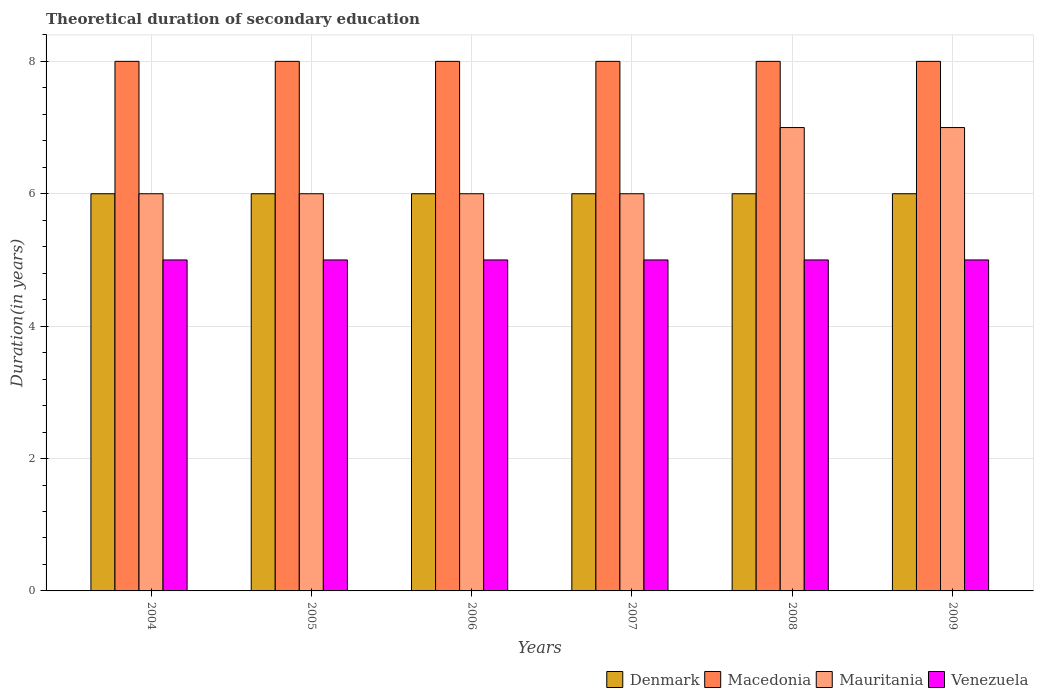How many different coloured bars are there?
Your answer should be very brief. 4. Are the number of bars per tick equal to the number of legend labels?
Offer a very short reply. Yes. Are the number of bars on each tick of the X-axis equal?
Give a very brief answer. Yes. How many bars are there on the 1st tick from the left?
Provide a succinct answer. 4. What is the label of the 4th group of bars from the left?
Your answer should be compact. 2007. In how many cases, is the number of bars for a given year not equal to the number of legend labels?
Your response must be concise. 0. What is the total theoretical duration of secondary education in Venezuela in 2004?
Provide a short and direct response. 5. Across all years, what is the maximum total theoretical duration of secondary education in Venezuela?
Your answer should be compact. 5. What is the total total theoretical duration of secondary education in Venezuela in the graph?
Ensure brevity in your answer.  30. What is the difference between the total theoretical duration of secondary education in Mauritania in 2006 and that in 2009?
Your response must be concise. -1. What is the difference between the total theoretical duration of secondary education in Denmark in 2005 and the total theoretical duration of secondary education in Mauritania in 2009?
Provide a short and direct response. -1. What is the average total theoretical duration of secondary education in Mauritania per year?
Give a very brief answer. 6.33. In the year 2005, what is the difference between the total theoretical duration of secondary education in Venezuela and total theoretical duration of secondary education in Denmark?
Your answer should be very brief. -1. What is the ratio of the total theoretical duration of secondary education in Mauritania in 2006 to that in 2009?
Your answer should be compact. 0.86. Is the difference between the total theoretical duration of secondary education in Venezuela in 2007 and 2008 greater than the difference between the total theoretical duration of secondary education in Denmark in 2007 and 2008?
Make the answer very short. No. What is the difference between the highest and the second highest total theoretical duration of secondary education in Denmark?
Make the answer very short. 0. In how many years, is the total theoretical duration of secondary education in Denmark greater than the average total theoretical duration of secondary education in Denmark taken over all years?
Your response must be concise. 0. Is the sum of the total theoretical duration of secondary education in Mauritania in 2004 and 2006 greater than the maximum total theoretical duration of secondary education in Macedonia across all years?
Keep it short and to the point. Yes. Is it the case that in every year, the sum of the total theoretical duration of secondary education in Venezuela and total theoretical duration of secondary education in Denmark is greater than the sum of total theoretical duration of secondary education in Macedonia and total theoretical duration of secondary education in Mauritania?
Your answer should be compact. No. What does the 2nd bar from the left in 2005 represents?
Your response must be concise. Macedonia. What does the 2nd bar from the right in 2008 represents?
Provide a short and direct response. Mauritania. How many bars are there?
Your response must be concise. 24. What is the difference between two consecutive major ticks on the Y-axis?
Provide a succinct answer. 2. Does the graph contain grids?
Offer a terse response. Yes. What is the title of the graph?
Your answer should be very brief. Theoretical duration of secondary education. What is the label or title of the X-axis?
Offer a terse response. Years. What is the label or title of the Y-axis?
Offer a very short reply. Duration(in years). What is the Duration(in years) in Denmark in 2004?
Ensure brevity in your answer.  6. What is the Duration(in years) of Macedonia in 2005?
Your answer should be compact. 8. What is the Duration(in years) of Venezuela in 2005?
Your answer should be very brief. 5. What is the Duration(in years) of Denmark in 2006?
Make the answer very short. 6. What is the Duration(in years) in Macedonia in 2006?
Provide a succinct answer. 8. What is the Duration(in years) of Venezuela in 2006?
Provide a succinct answer. 5. What is the Duration(in years) in Mauritania in 2007?
Keep it short and to the point. 6. What is the Duration(in years) of Denmark in 2008?
Keep it short and to the point. 6. What is the Duration(in years) of Macedonia in 2008?
Your answer should be compact. 8. What is the Duration(in years) in Mauritania in 2008?
Your response must be concise. 7. What is the Duration(in years) in Venezuela in 2008?
Offer a very short reply. 5. What is the Duration(in years) in Macedonia in 2009?
Keep it short and to the point. 8. What is the Duration(in years) of Mauritania in 2009?
Make the answer very short. 7. Across all years, what is the maximum Duration(in years) of Denmark?
Your answer should be compact. 6. Across all years, what is the maximum Duration(in years) in Mauritania?
Provide a short and direct response. 7. Across all years, what is the maximum Duration(in years) of Venezuela?
Give a very brief answer. 5. Across all years, what is the minimum Duration(in years) of Denmark?
Give a very brief answer. 6. Across all years, what is the minimum Duration(in years) in Macedonia?
Offer a terse response. 8. What is the total Duration(in years) of Denmark in the graph?
Give a very brief answer. 36. What is the total Duration(in years) of Macedonia in the graph?
Your answer should be very brief. 48. What is the total Duration(in years) in Mauritania in the graph?
Offer a very short reply. 38. What is the total Duration(in years) in Venezuela in the graph?
Ensure brevity in your answer.  30. What is the difference between the Duration(in years) in Mauritania in 2004 and that in 2005?
Offer a very short reply. 0. What is the difference between the Duration(in years) of Macedonia in 2004 and that in 2006?
Offer a very short reply. 0. What is the difference between the Duration(in years) of Mauritania in 2004 and that in 2006?
Your answer should be compact. 0. What is the difference between the Duration(in years) of Venezuela in 2004 and that in 2006?
Your answer should be compact. 0. What is the difference between the Duration(in years) of Denmark in 2004 and that in 2007?
Offer a very short reply. 0. What is the difference between the Duration(in years) of Macedonia in 2004 and that in 2007?
Give a very brief answer. 0. What is the difference between the Duration(in years) in Mauritania in 2004 and that in 2007?
Provide a succinct answer. 0. What is the difference between the Duration(in years) of Venezuela in 2004 and that in 2007?
Keep it short and to the point. 0. What is the difference between the Duration(in years) in Denmark in 2004 and that in 2008?
Your answer should be compact. 0. What is the difference between the Duration(in years) of Macedonia in 2004 and that in 2008?
Keep it short and to the point. 0. What is the difference between the Duration(in years) in Mauritania in 2004 and that in 2008?
Make the answer very short. -1. What is the difference between the Duration(in years) of Denmark in 2004 and that in 2009?
Offer a very short reply. 0. What is the difference between the Duration(in years) in Macedonia in 2004 and that in 2009?
Your answer should be compact. 0. What is the difference between the Duration(in years) of Venezuela in 2004 and that in 2009?
Provide a short and direct response. 0. What is the difference between the Duration(in years) in Macedonia in 2005 and that in 2006?
Provide a short and direct response. 0. What is the difference between the Duration(in years) of Mauritania in 2005 and that in 2006?
Your response must be concise. 0. What is the difference between the Duration(in years) in Venezuela in 2005 and that in 2006?
Keep it short and to the point. 0. What is the difference between the Duration(in years) in Macedonia in 2005 and that in 2007?
Your response must be concise. 0. What is the difference between the Duration(in years) in Denmark in 2005 and that in 2008?
Give a very brief answer. 0. What is the difference between the Duration(in years) in Mauritania in 2005 and that in 2008?
Give a very brief answer. -1. What is the difference between the Duration(in years) of Venezuela in 2005 and that in 2008?
Your answer should be compact. 0. What is the difference between the Duration(in years) in Venezuela in 2005 and that in 2009?
Ensure brevity in your answer.  0. What is the difference between the Duration(in years) in Denmark in 2006 and that in 2007?
Offer a terse response. 0. What is the difference between the Duration(in years) in Macedonia in 2006 and that in 2007?
Your response must be concise. 0. What is the difference between the Duration(in years) in Macedonia in 2006 and that in 2008?
Give a very brief answer. 0. What is the difference between the Duration(in years) in Mauritania in 2006 and that in 2008?
Ensure brevity in your answer.  -1. What is the difference between the Duration(in years) in Venezuela in 2006 and that in 2008?
Provide a short and direct response. 0. What is the difference between the Duration(in years) of Macedonia in 2006 and that in 2009?
Keep it short and to the point. 0. What is the difference between the Duration(in years) of Mauritania in 2006 and that in 2009?
Your response must be concise. -1. What is the difference between the Duration(in years) in Venezuela in 2006 and that in 2009?
Your answer should be compact. 0. What is the difference between the Duration(in years) of Denmark in 2007 and that in 2008?
Make the answer very short. 0. What is the difference between the Duration(in years) in Mauritania in 2007 and that in 2008?
Provide a short and direct response. -1. What is the difference between the Duration(in years) of Venezuela in 2007 and that in 2008?
Provide a short and direct response. 0. What is the difference between the Duration(in years) in Macedonia in 2007 and that in 2009?
Make the answer very short. 0. What is the difference between the Duration(in years) of Venezuela in 2007 and that in 2009?
Your answer should be compact. 0. What is the difference between the Duration(in years) of Venezuela in 2008 and that in 2009?
Offer a very short reply. 0. What is the difference between the Duration(in years) in Denmark in 2004 and the Duration(in years) in Venezuela in 2005?
Keep it short and to the point. 1. What is the difference between the Duration(in years) in Macedonia in 2004 and the Duration(in years) in Mauritania in 2005?
Ensure brevity in your answer.  2. What is the difference between the Duration(in years) of Denmark in 2004 and the Duration(in years) of Mauritania in 2006?
Make the answer very short. 0. What is the difference between the Duration(in years) in Denmark in 2004 and the Duration(in years) in Venezuela in 2006?
Ensure brevity in your answer.  1. What is the difference between the Duration(in years) in Macedonia in 2004 and the Duration(in years) in Mauritania in 2007?
Provide a succinct answer. 2. What is the difference between the Duration(in years) in Macedonia in 2004 and the Duration(in years) in Venezuela in 2007?
Your answer should be very brief. 3. What is the difference between the Duration(in years) of Denmark in 2004 and the Duration(in years) of Macedonia in 2008?
Provide a short and direct response. -2. What is the difference between the Duration(in years) in Denmark in 2004 and the Duration(in years) in Mauritania in 2008?
Make the answer very short. -1. What is the difference between the Duration(in years) in Denmark in 2004 and the Duration(in years) in Venezuela in 2008?
Keep it short and to the point. 1. What is the difference between the Duration(in years) of Mauritania in 2004 and the Duration(in years) of Venezuela in 2008?
Provide a succinct answer. 1. What is the difference between the Duration(in years) of Denmark in 2004 and the Duration(in years) of Venezuela in 2009?
Your response must be concise. 1. What is the difference between the Duration(in years) in Macedonia in 2004 and the Duration(in years) in Venezuela in 2009?
Give a very brief answer. 3. What is the difference between the Duration(in years) of Mauritania in 2004 and the Duration(in years) of Venezuela in 2009?
Keep it short and to the point. 1. What is the difference between the Duration(in years) of Denmark in 2005 and the Duration(in years) of Macedonia in 2006?
Offer a terse response. -2. What is the difference between the Duration(in years) in Denmark in 2005 and the Duration(in years) in Venezuela in 2006?
Your answer should be very brief. 1. What is the difference between the Duration(in years) of Macedonia in 2005 and the Duration(in years) of Venezuela in 2006?
Your answer should be compact. 3. What is the difference between the Duration(in years) in Denmark in 2005 and the Duration(in years) in Macedonia in 2007?
Offer a terse response. -2. What is the difference between the Duration(in years) of Macedonia in 2005 and the Duration(in years) of Mauritania in 2007?
Ensure brevity in your answer.  2. What is the difference between the Duration(in years) of Macedonia in 2005 and the Duration(in years) of Venezuela in 2007?
Your answer should be very brief. 3. What is the difference between the Duration(in years) of Denmark in 2005 and the Duration(in years) of Macedonia in 2008?
Your response must be concise. -2. What is the difference between the Duration(in years) of Denmark in 2005 and the Duration(in years) of Mauritania in 2008?
Offer a terse response. -1. What is the difference between the Duration(in years) in Denmark in 2005 and the Duration(in years) in Venezuela in 2008?
Give a very brief answer. 1. What is the difference between the Duration(in years) in Macedonia in 2005 and the Duration(in years) in Venezuela in 2008?
Keep it short and to the point. 3. What is the difference between the Duration(in years) of Mauritania in 2005 and the Duration(in years) of Venezuela in 2008?
Keep it short and to the point. 1. What is the difference between the Duration(in years) in Macedonia in 2005 and the Duration(in years) in Mauritania in 2009?
Your answer should be compact. 1. What is the difference between the Duration(in years) in Mauritania in 2006 and the Duration(in years) in Venezuela in 2007?
Make the answer very short. 1. What is the difference between the Duration(in years) of Denmark in 2006 and the Duration(in years) of Macedonia in 2008?
Offer a very short reply. -2. What is the difference between the Duration(in years) in Macedonia in 2006 and the Duration(in years) in Venezuela in 2008?
Keep it short and to the point. 3. What is the difference between the Duration(in years) in Mauritania in 2006 and the Duration(in years) in Venezuela in 2008?
Give a very brief answer. 1. What is the difference between the Duration(in years) of Denmark in 2006 and the Duration(in years) of Mauritania in 2009?
Give a very brief answer. -1. What is the difference between the Duration(in years) in Denmark in 2006 and the Duration(in years) in Venezuela in 2009?
Offer a terse response. 1. What is the difference between the Duration(in years) of Macedonia in 2006 and the Duration(in years) of Mauritania in 2009?
Your response must be concise. 1. What is the difference between the Duration(in years) of Mauritania in 2006 and the Duration(in years) of Venezuela in 2009?
Your answer should be compact. 1. What is the difference between the Duration(in years) in Denmark in 2007 and the Duration(in years) in Macedonia in 2008?
Keep it short and to the point. -2. What is the difference between the Duration(in years) of Macedonia in 2007 and the Duration(in years) of Mauritania in 2008?
Make the answer very short. 1. What is the difference between the Duration(in years) of Macedonia in 2007 and the Duration(in years) of Mauritania in 2009?
Your answer should be very brief. 1. What is the difference between the Duration(in years) of Mauritania in 2007 and the Duration(in years) of Venezuela in 2009?
Keep it short and to the point. 1. What is the difference between the Duration(in years) in Denmark in 2008 and the Duration(in years) in Mauritania in 2009?
Make the answer very short. -1. What is the difference between the Duration(in years) of Denmark in 2008 and the Duration(in years) of Venezuela in 2009?
Make the answer very short. 1. What is the average Duration(in years) of Macedonia per year?
Keep it short and to the point. 8. What is the average Duration(in years) of Mauritania per year?
Your answer should be compact. 6.33. What is the average Duration(in years) of Venezuela per year?
Provide a succinct answer. 5. In the year 2004, what is the difference between the Duration(in years) of Denmark and Duration(in years) of Venezuela?
Your answer should be very brief. 1. In the year 2004, what is the difference between the Duration(in years) of Macedonia and Duration(in years) of Venezuela?
Your answer should be compact. 3. In the year 2004, what is the difference between the Duration(in years) of Mauritania and Duration(in years) of Venezuela?
Your response must be concise. 1. In the year 2005, what is the difference between the Duration(in years) of Denmark and Duration(in years) of Mauritania?
Your answer should be very brief. 0. In the year 2005, what is the difference between the Duration(in years) of Macedonia and Duration(in years) of Venezuela?
Ensure brevity in your answer.  3. In the year 2005, what is the difference between the Duration(in years) of Mauritania and Duration(in years) of Venezuela?
Offer a very short reply. 1. In the year 2006, what is the difference between the Duration(in years) of Denmark and Duration(in years) of Venezuela?
Your response must be concise. 1. In the year 2006, what is the difference between the Duration(in years) of Mauritania and Duration(in years) of Venezuela?
Give a very brief answer. 1. In the year 2007, what is the difference between the Duration(in years) of Denmark and Duration(in years) of Macedonia?
Your answer should be very brief. -2. In the year 2007, what is the difference between the Duration(in years) of Denmark and Duration(in years) of Venezuela?
Your answer should be very brief. 1. In the year 2007, what is the difference between the Duration(in years) of Macedonia and Duration(in years) of Mauritania?
Your answer should be compact. 2. In the year 2007, what is the difference between the Duration(in years) in Macedonia and Duration(in years) in Venezuela?
Your response must be concise. 3. In the year 2007, what is the difference between the Duration(in years) in Mauritania and Duration(in years) in Venezuela?
Your answer should be compact. 1. In the year 2008, what is the difference between the Duration(in years) in Denmark and Duration(in years) in Macedonia?
Provide a short and direct response. -2. In the year 2008, what is the difference between the Duration(in years) in Macedonia and Duration(in years) in Venezuela?
Give a very brief answer. 3. In the year 2008, what is the difference between the Duration(in years) of Mauritania and Duration(in years) of Venezuela?
Give a very brief answer. 2. In the year 2009, what is the difference between the Duration(in years) of Denmark and Duration(in years) of Venezuela?
Offer a very short reply. 1. In the year 2009, what is the difference between the Duration(in years) of Macedonia and Duration(in years) of Mauritania?
Ensure brevity in your answer.  1. In the year 2009, what is the difference between the Duration(in years) in Mauritania and Duration(in years) in Venezuela?
Ensure brevity in your answer.  2. What is the ratio of the Duration(in years) in Macedonia in 2004 to that in 2005?
Keep it short and to the point. 1. What is the ratio of the Duration(in years) in Denmark in 2004 to that in 2006?
Your answer should be very brief. 1. What is the ratio of the Duration(in years) of Macedonia in 2004 to that in 2006?
Offer a terse response. 1. What is the ratio of the Duration(in years) in Mauritania in 2004 to that in 2006?
Your answer should be very brief. 1. What is the ratio of the Duration(in years) of Denmark in 2004 to that in 2007?
Give a very brief answer. 1. What is the ratio of the Duration(in years) of Mauritania in 2004 to that in 2007?
Offer a terse response. 1. What is the ratio of the Duration(in years) in Macedonia in 2004 to that in 2009?
Your answer should be compact. 1. What is the ratio of the Duration(in years) of Mauritania in 2004 to that in 2009?
Offer a terse response. 0.86. What is the ratio of the Duration(in years) of Macedonia in 2005 to that in 2006?
Offer a terse response. 1. What is the ratio of the Duration(in years) in Mauritania in 2005 to that in 2006?
Ensure brevity in your answer.  1. What is the ratio of the Duration(in years) in Venezuela in 2005 to that in 2006?
Your response must be concise. 1. What is the ratio of the Duration(in years) of Venezuela in 2005 to that in 2007?
Your answer should be very brief. 1. What is the ratio of the Duration(in years) of Denmark in 2005 to that in 2008?
Your response must be concise. 1. What is the ratio of the Duration(in years) in Macedonia in 2005 to that in 2008?
Provide a succinct answer. 1. What is the ratio of the Duration(in years) of Venezuela in 2005 to that in 2008?
Offer a terse response. 1. What is the ratio of the Duration(in years) of Mauritania in 2005 to that in 2009?
Keep it short and to the point. 0.86. What is the ratio of the Duration(in years) of Denmark in 2006 to that in 2007?
Provide a short and direct response. 1. What is the ratio of the Duration(in years) of Denmark in 2006 to that in 2008?
Provide a short and direct response. 1. What is the ratio of the Duration(in years) in Mauritania in 2006 to that in 2008?
Ensure brevity in your answer.  0.86. What is the ratio of the Duration(in years) of Denmark in 2006 to that in 2009?
Offer a terse response. 1. What is the ratio of the Duration(in years) in Macedonia in 2006 to that in 2009?
Your answer should be very brief. 1. What is the ratio of the Duration(in years) of Mauritania in 2006 to that in 2009?
Offer a very short reply. 0.86. What is the ratio of the Duration(in years) in Denmark in 2007 to that in 2008?
Your answer should be compact. 1. What is the ratio of the Duration(in years) of Mauritania in 2007 to that in 2008?
Make the answer very short. 0.86. What is the ratio of the Duration(in years) in Denmark in 2007 to that in 2009?
Make the answer very short. 1. What is the ratio of the Duration(in years) of Macedonia in 2007 to that in 2009?
Offer a terse response. 1. What is the ratio of the Duration(in years) in Denmark in 2008 to that in 2009?
Your answer should be very brief. 1. What is the ratio of the Duration(in years) in Venezuela in 2008 to that in 2009?
Provide a succinct answer. 1. What is the difference between the highest and the second highest Duration(in years) in Denmark?
Your answer should be very brief. 0. What is the difference between the highest and the second highest Duration(in years) in Venezuela?
Offer a very short reply. 0. What is the difference between the highest and the lowest Duration(in years) in Denmark?
Ensure brevity in your answer.  0. What is the difference between the highest and the lowest Duration(in years) of Macedonia?
Provide a short and direct response. 0. 